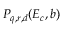Convert formula to latex. <formula><loc_0><loc_0><loc_500><loc_500>P _ { q , r , d } ( E _ { c } , b )</formula> 